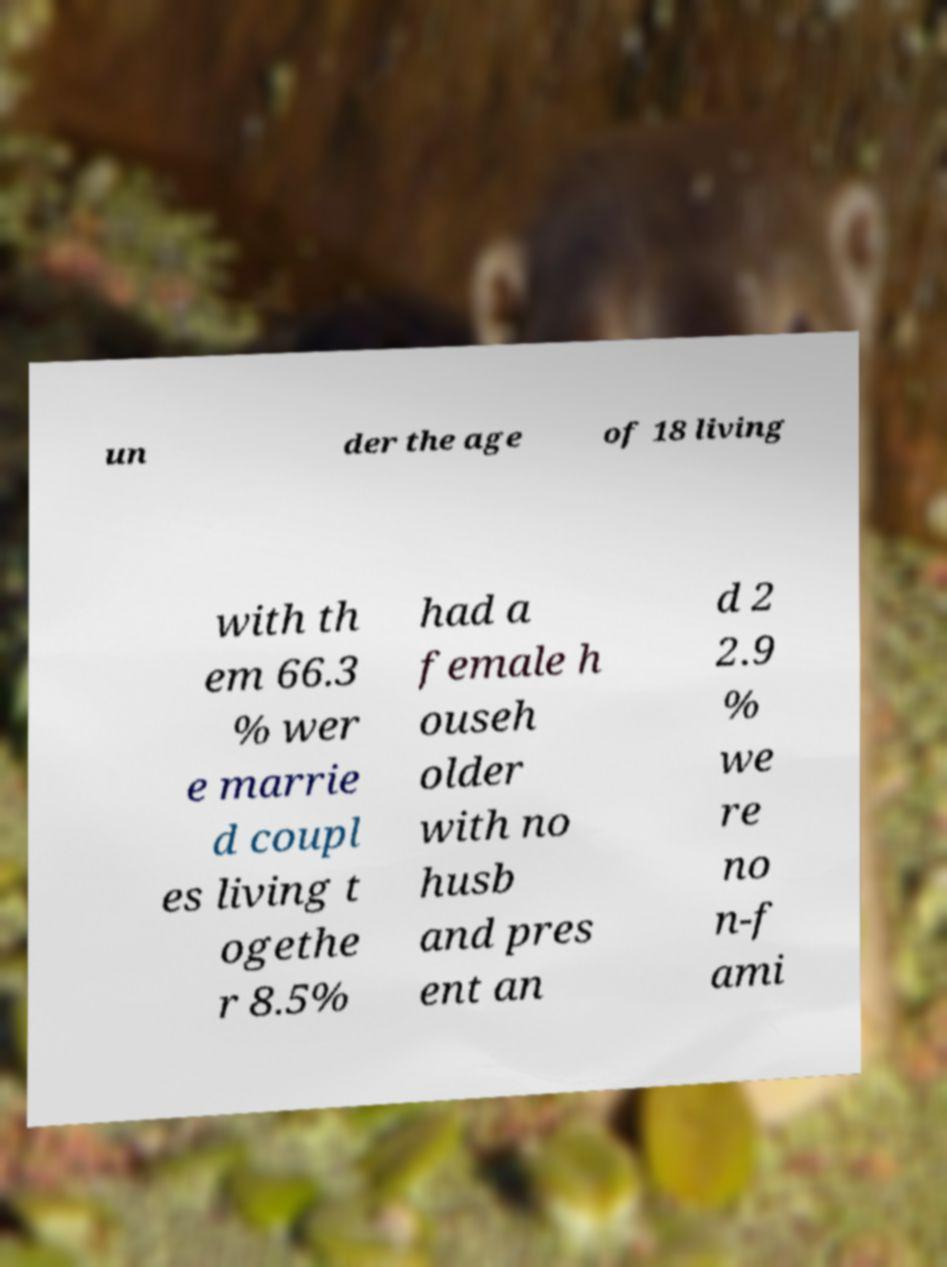Please read and relay the text visible in this image. What does it say? un der the age of 18 living with th em 66.3 % wer e marrie d coupl es living t ogethe r 8.5% had a female h ouseh older with no husb and pres ent an d 2 2.9 % we re no n-f ami 